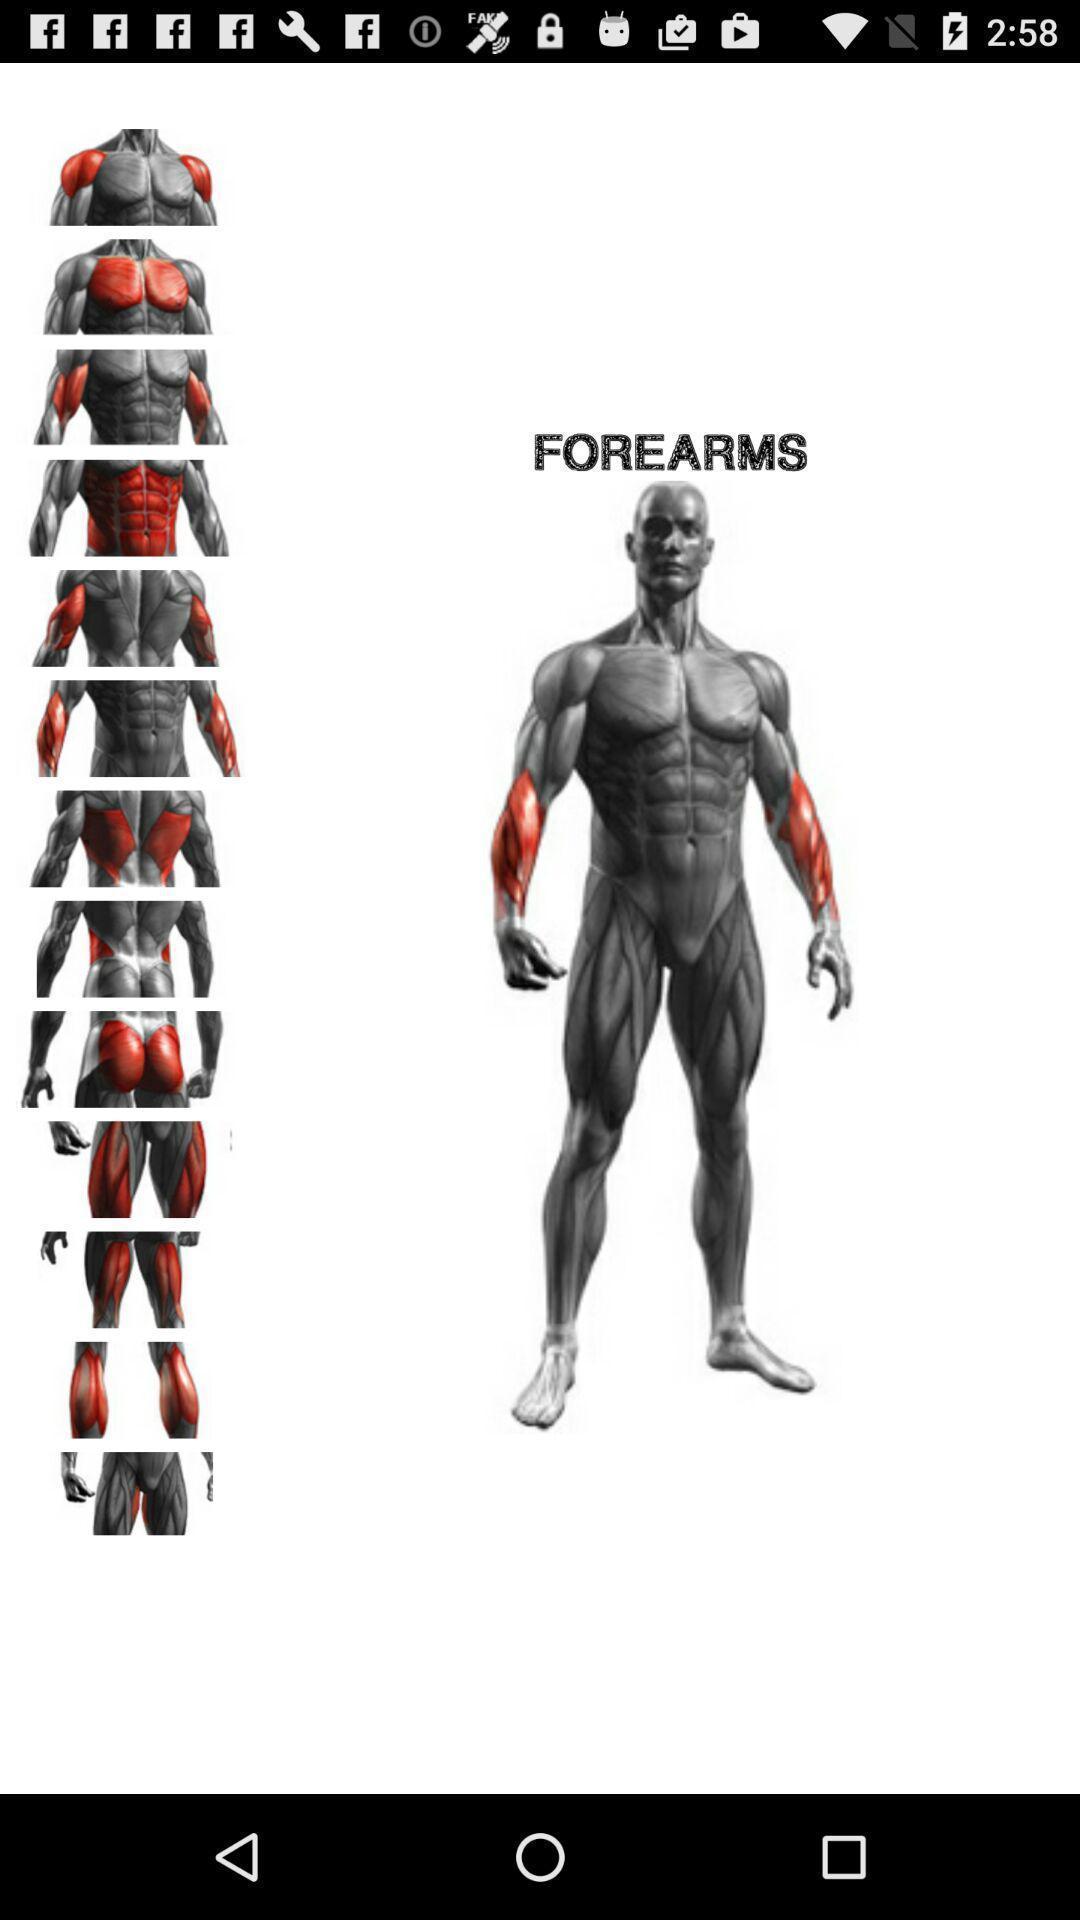What details can you identify in this image? Page of a fitness and bodybuilding application. 